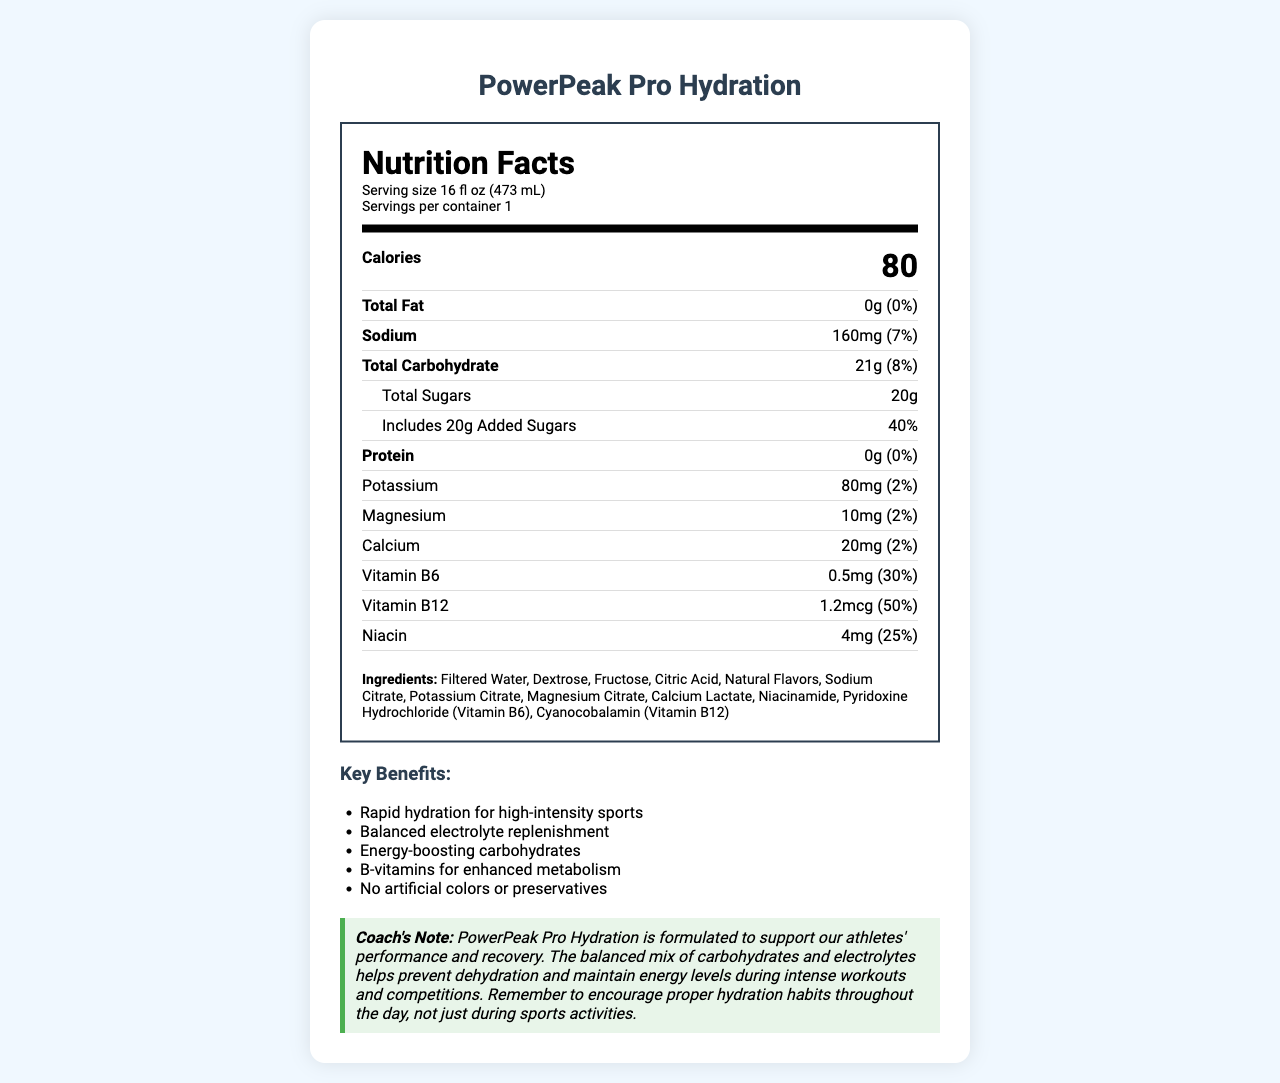what is the product name? The product name is clearly stated at the top of the document.
Answer: PowerPeak Pro Hydration how many calories are in each serving? The document lists 80 calories per serving.
Answer: 80 what is the amount of total sugars per serving? Under the 'Total Sugars' section, the amount listed is 20g.
Answer: 20g how much sodium is in one serving? The sodium content per serving is listed as 160mg.
Answer: 160mg does the drink contain any protein? The document shows 0g of protein, which is 0% of the daily value.
Answer: No what vitamins are included in PowerPeak Pro Hydration? A. Vitamin A, Vitamin C, Vitamin D B. Vitamin B6, Vitamin B12, Niacin C. Vitamin E, Biotin, Folate D. Thiamine, Riboflavin, Pantothenic Acid The drink contains Vitamin B6 (0.5mg), Vitamin B12 (1.2mcg), and Niacin (4mg).
Answer: B how much of the daily value of Vitamin B12 does each serving provide? A. 10% B. 30% C. 50% D. 70% Each serving provides 50% of the daily value of Vitamin B12.
Answer: C is this drink primarily designed for hydration during physical activity? The key benefits and recommended use sections explain that the drink is made for hydration during intense physical activity.
Answer: Yes what are the key benefits of PowerPeak Pro Hydration? The document lists these points in the "Key Benefits" section, highlighting the major advantages of the drink.
Answer: Rapid hydration for high-intensity sports, Balanced electrolyte replenishment, Energy-boosting carbohydrates, B-vitamins for enhanced metabolism, No artificial colors or preservatives what is the source of most of the energy in this drink? The drink contains 21g of total carbohydrates, which provide a major energy source.
Answer: Carbohydrates summarize the main idea of the document. This summary encapsulates the main points related to the drink's nutritional content, benefits, and usage.
Answer: PowerPeak Pro Hydration is a sports drink specifically designed for athletes, providing hydration, key electrolytes, and B-vitamins. It contains 80 calories per serving, mostly from carbohydrates, and includes minerals such as potassium, magnesium, and calcium. The drink offers rapid hydration, balanced electrolyte replenishment, and energy-boosting carbohydrates without artificial colors or preservatives. It is recommended for use before, during, or after intense physical activity. what are the main electrolytes in the drink and their amounts? These amounts are listed in the sections detailing each mineral.
Answer: Sodium: 160mg, Potassium: 80mg, Magnesium: 10mg, Calcium: 20mg does the drink contain any fats? The total fat content is listed as 0g, which is 0% of the daily value.
Answer: No what ingredients are used in this sports drink? The document includes a detailed list of ingredients used in PowerPeak Pro Hydration.
Answer: Filtered Water, Dextrose, Fructose, Citric Acid, Natural Flavors, Sodium Citrate, Potassium Citrate, Magnesium Citrate, Calcium Lactate, Niacinamide, Pyridoxine Hydrochloride (Vitamin B6), Cyanocobalamin (Vitamin B12) can you determine the exact amount of Vitamin C in the drink? The document does not mention Vitamin C or its amount, so this information cannot be determined from it.
Answer: Cannot be determined 